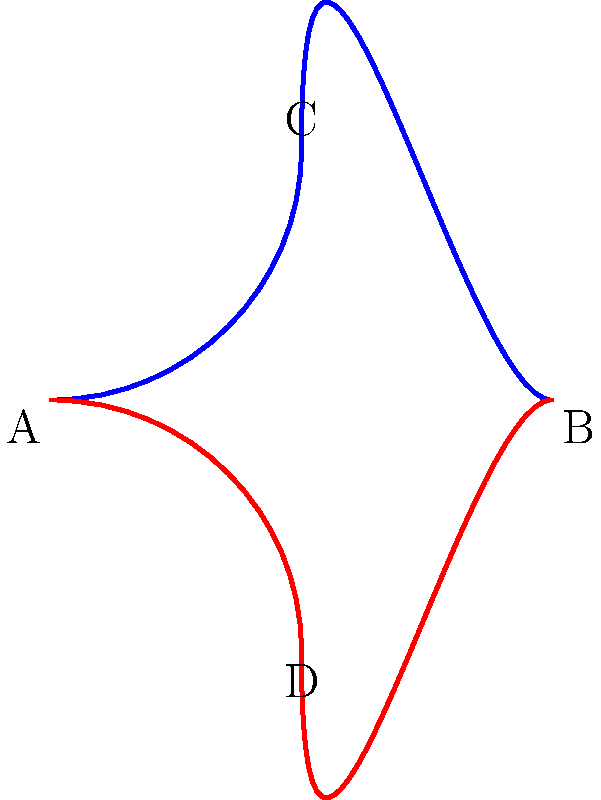Consider the two chromosome structures shown above during cell division. If we define a homeomorphism $f: X \to Y$ between topological spaces $X$ and $Y$ as a bijective function that is continuous in both directions, which of the following statements is true?

a) The blue and red structures are homeomorphic
b) The blue structure is homeomorphic to a circle
c) The red structure is homeomorphic to a line segment
d) Neither structure is homeomorphic to any simple geometric shape Let's approach this step-by-step:

1) First, recall that homeomorphisms preserve topological properties. Two objects are homeomorphic if one can be deformed into the other without cutting or gluing.

2) The blue structure (chromosome1) is a simple curve with no self-intersections. It can be continuously deformed into a circle without breaking or joining any points.

3) The red structure (chromosome2) is also a simple curve with no self-intersections. It can be continuously deformed into a line segment by "straightening out" the curve.

4) Both structures are homeomorphic to each other because they can both be deformed into a line segment (and thus into each other) without any topological changes.

5) The blue structure is homeomorphic to a circle, as mentioned in step 2.

6) The red structure is homeomorphic to a line segment, as mentioned in step 3.

7) Both structures are indeed homeomorphic to simple geometric shapes (circle and line segment).

Therefore, statements a, b, and c are all true, while d is false.
Answer: a, b, and c are true 